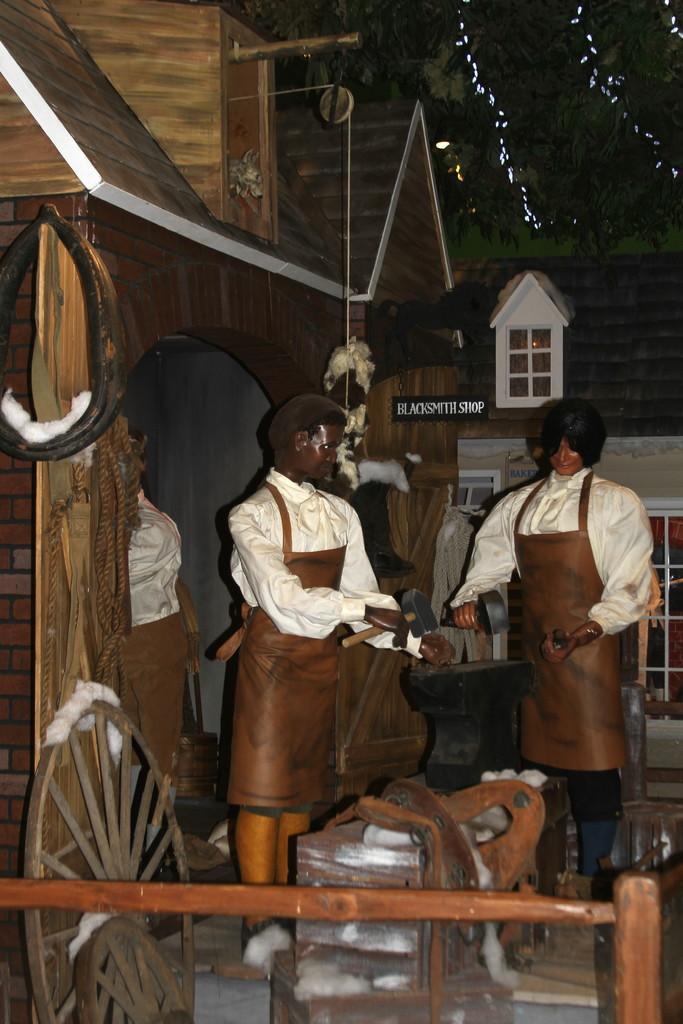In one or two sentences, can you explain what this image depicts? This picture is clicked inside. In the foreground we can see the wooden objects and a wheel. In the center we can see the sculptures of two persons holding some objects and standing on the ground. In the background we can see the house and the decoration lights and a tree. 